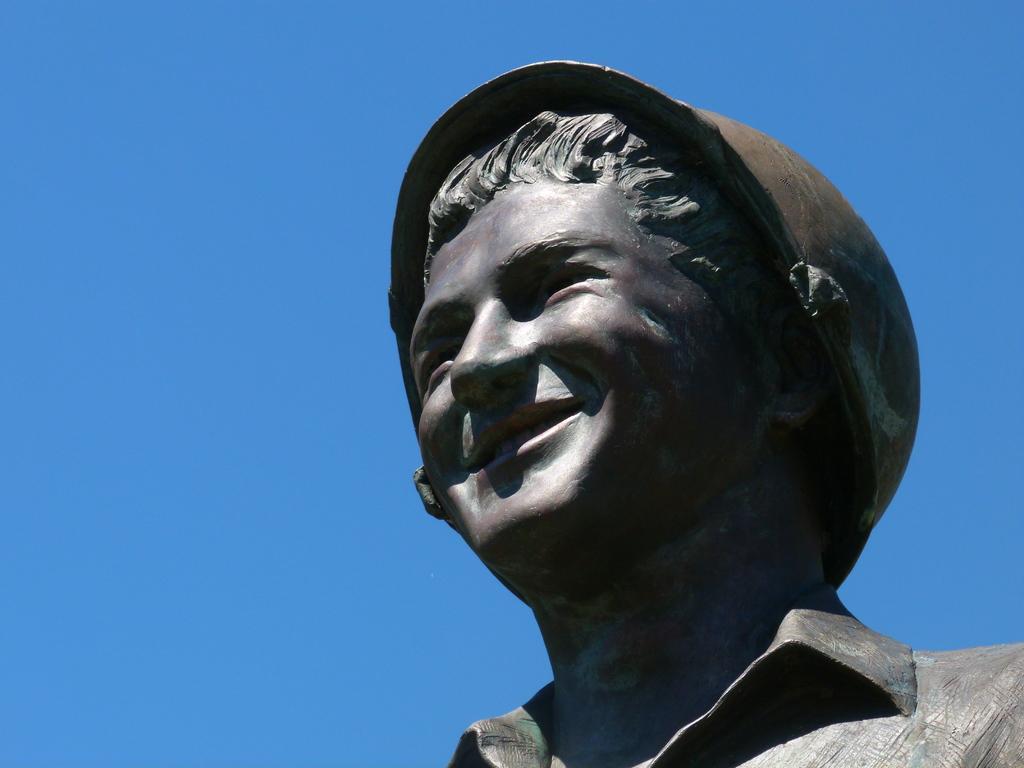Describe this image in one or two sentences. In this picture there is a statue of a person and he smiling. At the top there is sky. 